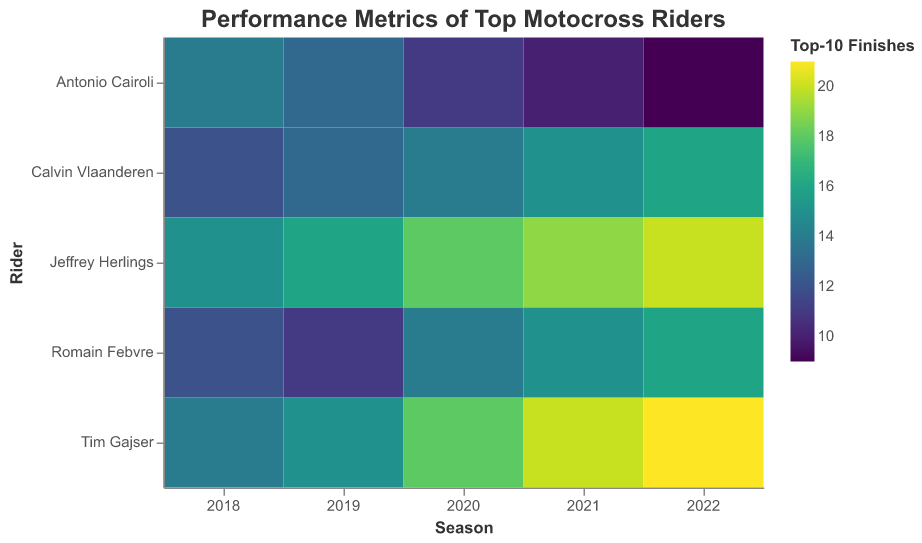What is the title of the heatmap? The title of the heatmap is usually displayed at the top of the heatmap.
Answer: Performance Metrics of Top Motocross Riders What are the axes labels in the heatmap? The axes labels can be found along the bottom (x-axis) and the side (y-axis) of the heatmap. The bottom axis is labeled "Season" and the side axis is labeled "Rider".
Answer: Season and Rider How does Calvin Vlaanderen's number of Top-10 Finishes change with age? To observe the change in Top-10 Finishes with age for Calvin Vlaanderen, look at his row and compare the color intensity across different seasons. The color gets more intense, indicating an increase in Top-10 Finishes.
Answer: Increases Which rider had the highest number of Top-10 Finishes in the 2022 season? To find this, look at the 2022 column and identify the rider with the most intense color, which represents the highest number of Top-10 Finishes. The most intense color indicates Tim Gajser with a value of 21.
Answer: Tim Gajser What is the range of podium finishes for Romain Febvre from 2018 to 2022? Check Romain Febvre's row and look at the podium finish values in each cell from 2018 to 2022 (8, 7, 9, 10, 11). The minimum is 7 and the maximum is 11, giving a range of 11 - 7 = 4.
Answer: 4 How many victories did Calvin Vlaanderen achieve by the 2022 season? Find Calvin Vlaanderen's row and look at the number of victories in the cell corresponding to the 2022 season.
Answer: 5 In which season did Antonio Cairoli have the most Top-10 Finishes? Check the cells in Antonio Cairoli's row and identify the season with the most intense color, indicating the highest number of Top-10 Finishes, which was in 2018.
Answer: 2018 Compare Jeffrey Herlings and Tim Gajser's victories in 2021. Who had more? Look at the 2021 column and compare the victories in Jeffrey Herlings' row and Tim Gajser's row. Jeffrey Herlings had 12 victories, whereas Tim Gajser had 10.
Answer: Jeffrey Herlings What is the average number of podium finishes for Calvin Vlaanderen from 2018 to 2022? Sum Calvin Vlaanderen's podium finishes (4, 5, 6, 7, 8) and divide by the number of seasons, which is 5 (4 + 5 + 6 + 7 + 8) / 5 = 6.
Answer: 6 